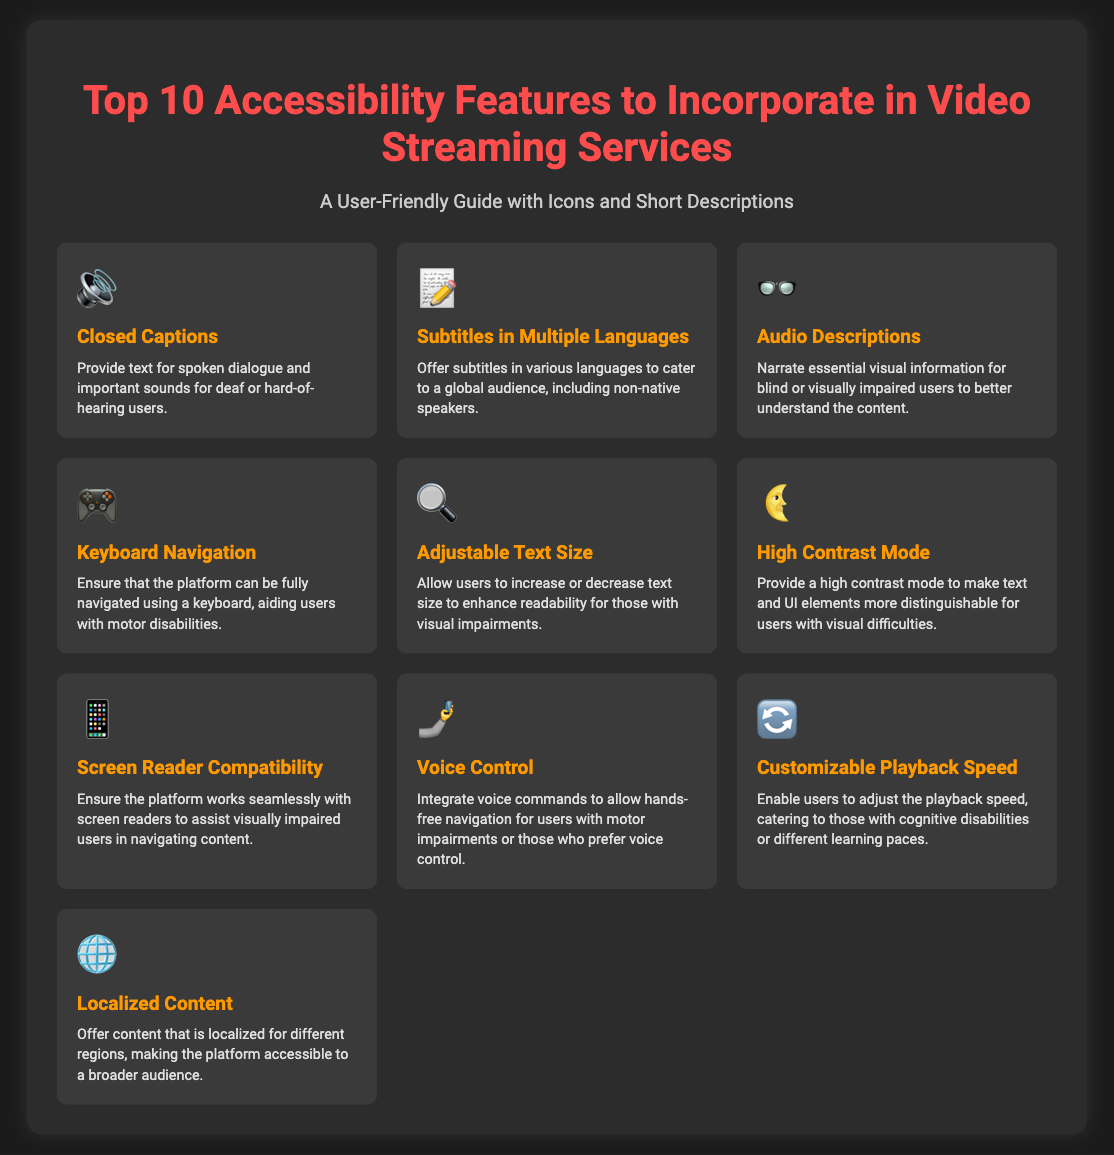What accessibility feature provides text for spoken dialogue? This feature is represented with the icon "🔊" and is specifically designed for deaf or hard-of-hearing users.
Answer: Closed Captions How many accessibility features are listed? The document specifies a total of ten features aimed at enhancing accessibility in video streaming services.
Answer: 10 What feature allows for hands-free navigation? This feature is depicted with the icon "🤳" and helps users with motor impairments navigate without using their hands.
Answer: Voice Control Which feature is used to narrate visual information? The icon "👓" represents this feature, which is essential for blind or visually impaired users to understand content better.
Answer: Audio Descriptions What accessibility feature allows users to change text size? Users can adjust text size for better readability, which is indicated by the icon "🔍" in the document.
Answer: Adjustable Text Size Which feature enhances visual content for users with difficulties? The icon "🌜" is associated with this feature that improves the distinction of text and UI elements.
Answer: High Contrast Mode What is the purpose of subtitles in multiple languages? This feature aids non-native speakers by providing translations in various languages, as indicated by the icon "📝".
Answer: Subtitles in Multiple Languages Which feature is essential for visually impaired users to navigate content? The icon "📱" identifies this important compatibility with assistive technology for navigation.
Answer: Screen Reader Compatibility What does customizable playback speed cater to? This feature helps accommodate users with cognitive disabilities or different learning paces, represented by the icon "🔄".
Answer: Customizable Playback Speed 